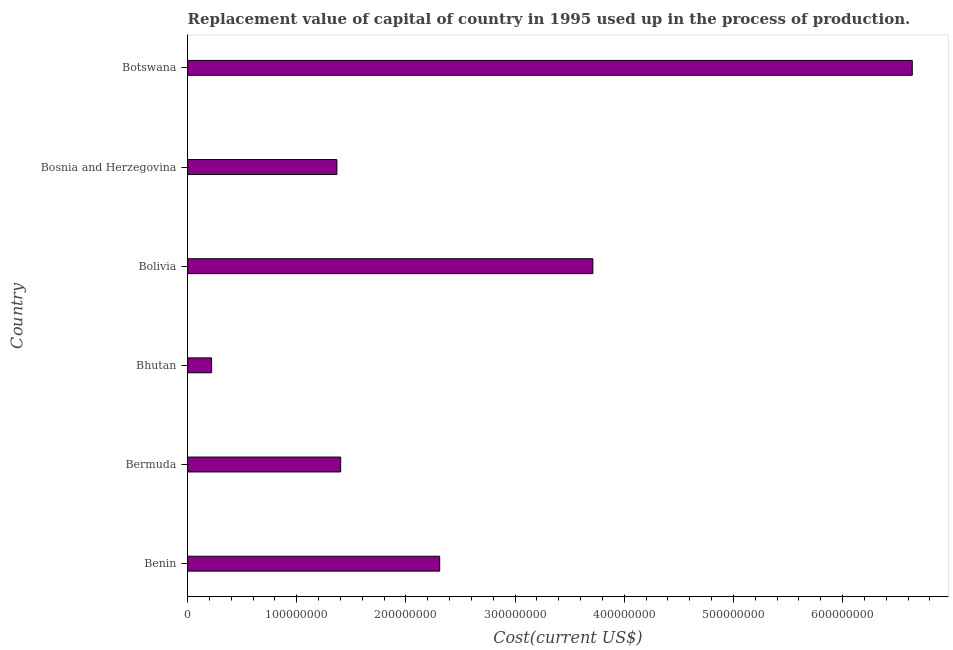What is the title of the graph?
Provide a short and direct response. Replacement value of capital of country in 1995 used up in the process of production. What is the label or title of the X-axis?
Your answer should be compact. Cost(current US$). What is the consumption of fixed capital in Bermuda?
Offer a very short reply. 1.40e+08. Across all countries, what is the maximum consumption of fixed capital?
Your answer should be very brief. 6.64e+08. Across all countries, what is the minimum consumption of fixed capital?
Offer a terse response. 2.20e+07. In which country was the consumption of fixed capital maximum?
Provide a succinct answer. Botswana. In which country was the consumption of fixed capital minimum?
Keep it short and to the point. Bhutan. What is the sum of the consumption of fixed capital?
Give a very brief answer. 1.57e+09. What is the difference between the consumption of fixed capital in Bermuda and Bhutan?
Make the answer very short. 1.18e+08. What is the average consumption of fixed capital per country?
Make the answer very short. 2.61e+08. What is the median consumption of fixed capital?
Make the answer very short. 1.86e+08. What is the ratio of the consumption of fixed capital in Benin to that in Bhutan?
Offer a very short reply. 10.51. Is the consumption of fixed capital in Bermuda less than that in Bosnia and Herzegovina?
Your response must be concise. No. What is the difference between the highest and the second highest consumption of fixed capital?
Your response must be concise. 2.93e+08. What is the difference between the highest and the lowest consumption of fixed capital?
Your answer should be very brief. 6.42e+08. In how many countries, is the consumption of fixed capital greater than the average consumption of fixed capital taken over all countries?
Offer a very short reply. 2. What is the difference between two consecutive major ticks on the X-axis?
Ensure brevity in your answer.  1.00e+08. Are the values on the major ticks of X-axis written in scientific E-notation?
Give a very brief answer. No. What is the Cost(current US$) in Benin?
Make the answer very short. 2.31e+08. What is the Cost(current US$) in Bermuda?
Ensure brevity in your answer.  1.40e+08. What is the Cost(current US$) in Bhutan?
Provide a short and direct response. 2.20e+07. What is the Cost(current US$) of Bolivia?
Your answer should be compact. 3.71e+08. What is the Cost(current US$) in Bosnia and Herzegovina?
Offer a very short reply. 1.37e+08. What is the Cost(current US$) of Botswana?
Ensure brevity in your answer.  6.64e+08. What is the difference between the Cost(current US$) in Benin and Bermuda?
Your response must be concise. 9.07e+07. What is the difference between the Cost(current US$) in Benin and Bhutan?
Make the answer very short. 2.09e+08. What is the difference between the Cost(current US$) in Benin and Bolivia?
Offer a very short reply. -1.40e+08. What is the difference between the Cost(current US$) in Benin and Bosnia and Herzegovina?
Provide a short and direct response. 9.42e+07. What is the difference between the Cost(current US$) in Benin and Botswana?
Give a very brief answer. -4.33e+08. What is the difference between the Cost(current US$) in Bermuda and Bhutan?
Ensure brevity in your answer.  1.18e+08. What is the difference between the Cost(current US$) in Bermuda and Bolivia?
Provide a succinct answer. -2.31e+08. What is the difference between the Cost(current US$) in Bermuda and Bosnia and Herzegovina?
Make the answer very short. 3.47e+06. What is the difference between the Cost(current US$) in Bermuda and Botswana?
Provide a succinct answer. -5.24e+08. What is the difference between the Cost(current US$) in Bhutan and Bolivia?
Provide a succinct answer. -3.49e+08. What is the difference between the Cost(current US$) in Bhutan and Bosnia and Herzegovina?
Keep it short and to the point. -1.15e+08. What is the difference between the Cost(current US$) in Bhutan and Botswana?
Offer a terse response. -6.42e+08. What is the difference between the Cost(current US$) in Bolivia and Bosnia and Herzegovina?
Keep it short and to the point. 2.35e+08. What is the difference between the Cost(current US$) in Bolivia and Botswana?
Offer a terse response. -2.93e+08. What is the difference between the Cost(current US$) in Bosnia and Herzegovina and Botswana?
Provide a short and direct response. -5.27e+08. What is the ratio of the Cost(current US$) in Benin to that in Bermuda?
Give a very brief answer. 1.65. What is the ratio of the Cost(current US$) in Benin to that in Bhutan?
Your response must be concise. 10.51. What is the ratio of the Cost(current US$) in Benin to that in Bolivia?
Offer a very short reply. 0.62. What is the ratio of the Cost(current US$) in Benin to that in Bosnia and Herzegovina?
Your response must be concise. 1.69. What is the ratio of the Cost(current US$) in Benin to that in Botswana?
Make the answer very short. 0.35. What is the ratio of the Cost(current US$) in Bermuda to that in Bhutan?
Ensure brevity in your answer.  6.38. What is the ratio of the Cost(current US$) in Bermuda to that in Bolivia?
Offer a very short reply. 0.38. What is the ratio of the Cost(current US$) in Bermuda to that in Botswana?
Your answer should be very brief. 0.21. What is the ratio of the Cost(current US$) in Bhutan to that in Bolivia?
Make the answer very short. 0.06. What is the ratio of the Cost(current US$) in Bhutan to that in Bosnia and Herzegovina?
Your answer should be compact. 0.16. What is the ratio of the Cost(current US$) in Bhutan to that in Botswana?
Your answer should be very brief. 0.03. What is the ratio of the Cost(current US$) in Bolivia to that in Bosnia and Herzegovina?
Keep it short and to the point. 2.71. What is the ratio of the Cost(current US$) in Bolivia to that in Botswana?
Give a very brief answer. 0.56. What is the ratio of the Cost(current US$) in Bosnia and Herzegovina to that in Botswana?
Offer a terse response. 0.21. 